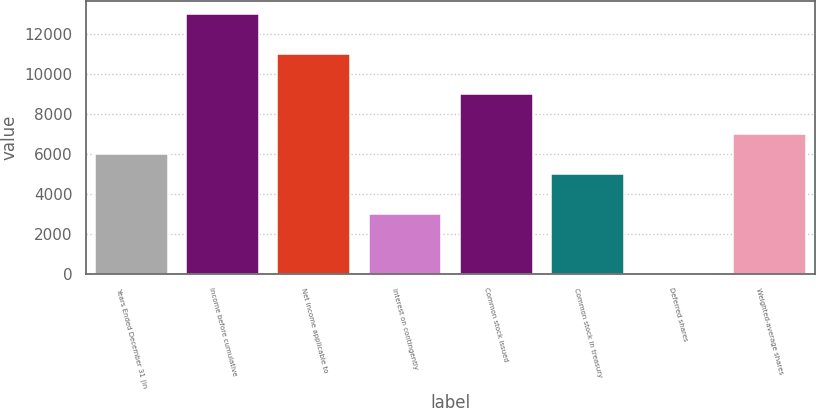<chart> <loc_0><loc_0><loc_500><loc_500><bar_chart><fcel>Years Ended December 31 (in<fcel>Income before cumulative<fcel>Net income applicable to<fcel>Interest on contingently<fcel>Common stock issued<fcel>Common stock in treasury<fcel>Deferred shares<fcel>Weighted-average shares<nl><fcel>5996.8<fcel>12991.9<fcel>10993.3<fcel>2998.9<fcel>8994.7<fcel>4997.5<fcel>1<fcel>6996.1<nl></chart> 